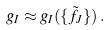Convert formula to latex. <formula><loc_0><loc_0><loc_500><loc_500>g _ { I } \approx g _ { I } ( \{ \tilde { f } _ { J } \} ) \, .</formula> 